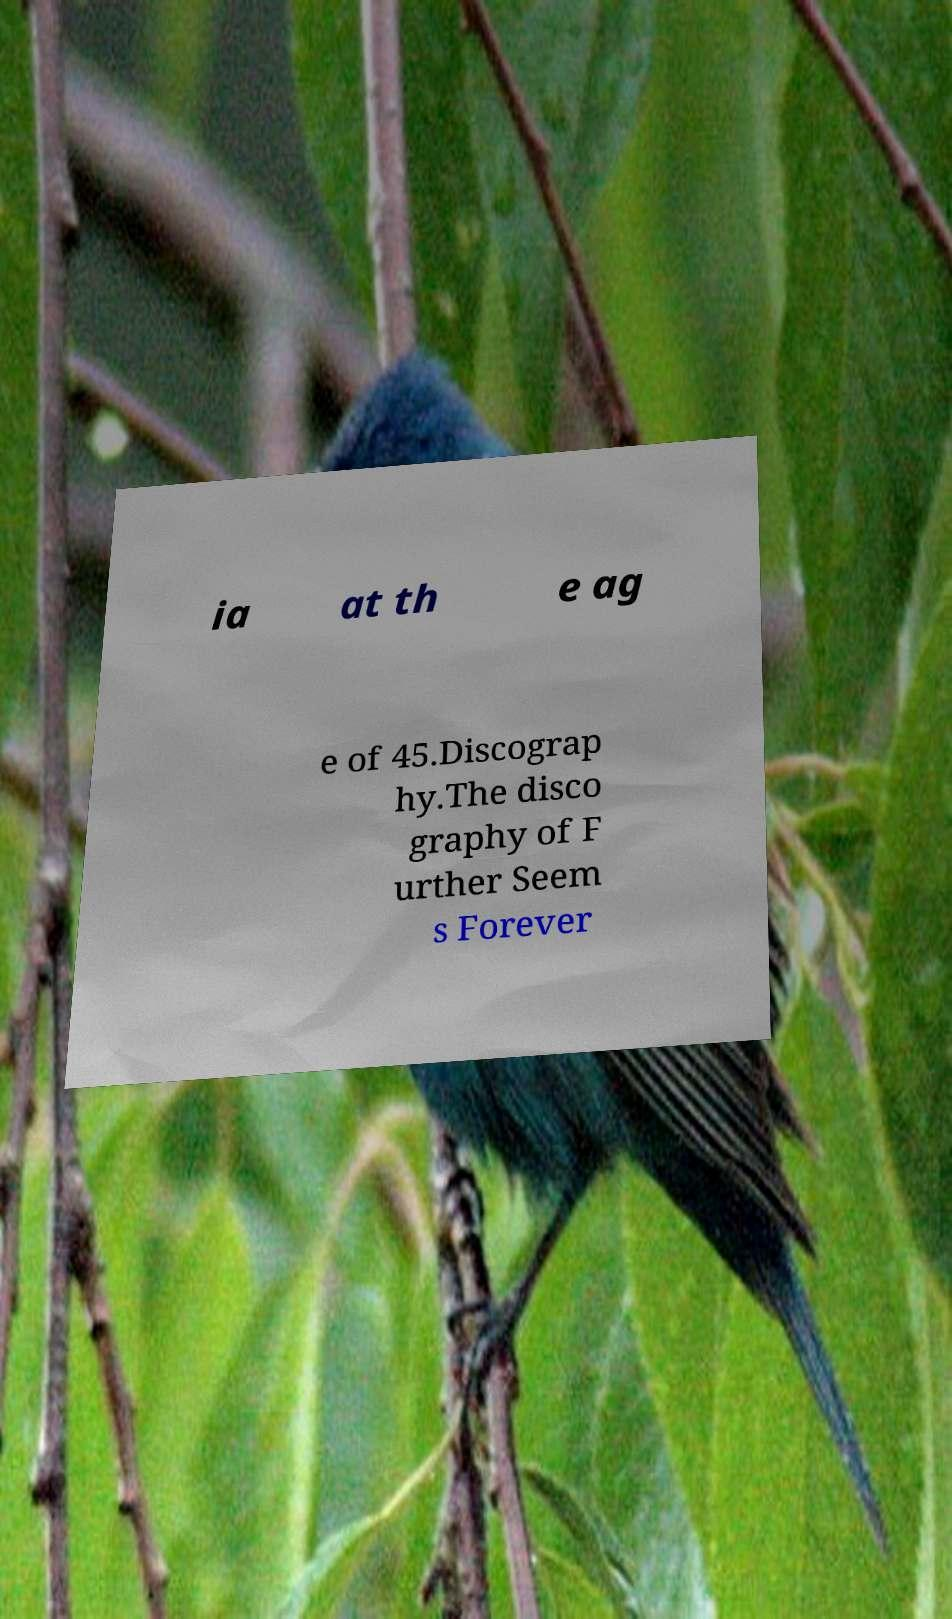Could you extract and type out the text from this image? ia at th e ag e of 45.Discograp hy.The disco graphy of F urther Seem s Forever 